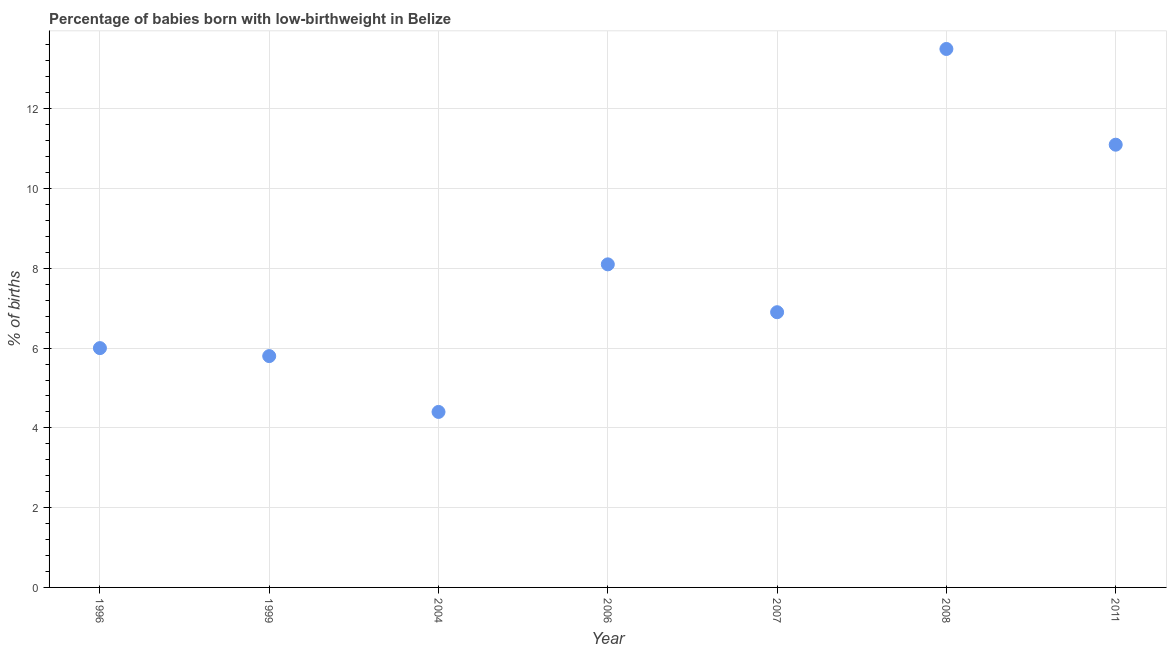Across all years, what is the maximum percentage of babies who were born with low-birthweight?
Provide a succinct answer. 13.5. Across all years, what is the minimum percentage of babies who were born with low-birthweight?
Your answer should be compact. 4.4. What is the sum of the percentage of babies who were born with low-birthweight?
Ensure brevity in your answer.  55.8. What is the average percentage of babies who were born with low-birthweight per year?
Provide a succinct answer. 7.97. In how many years, is the percentage of babies who were born with low-birthweight greater than 2.8 %?
Give a very brief answer. 7. What is the ratio of the percentage of babies who were born with low-birthweight in 2007 to that in 2011?
Your answer should be compact. 0.62. Is the percentage of babies who were born with low-birthweight in 2008 less than that in 2011?
Offer a very short reply. No. Is the difference between the percentage of babies who were born with low-birthweight in 1996 and 2004 greater than the difference between any two years?
Offer a very short reply. No. What is the difference between the highest and the second highest percentage of babies who were born with low-birthweight?
Your answer should be compact. 2.4. Is the sum of the percentage of babies who were born with low-birthweight in 2006 and 2007 greater than the maximum percentage of babies who were born with low-birthweight across all years?
Your response must be concise. Yes. What is the difference between the highest and the lowest percentage of babies who were born with low-birthweight?
Offer a terse response. 9.1. In how many years, is the percentage of babies who were born with low-birthweight greater than the average percentage of babies who were born with low-birthweight taken over all years?
Give a very brief answer. 3. Does the percentage of babies who were born with low-birthweight monotonically increase over the years?
Ensure brevity in your answer.  No. What is the difference between two consecutive major ticks on the Y-axis?
Offer a terse response. 2. Are the values on the major ticks of Y-axis written in scientific E-notation?
Make the answer very short. No. Does the graph contain any zero values?
Your answer should be very brief. No. Does the graph contain grids?
Make the answer very short. Yes. What is the title of the graph?
Keep it short and to the point. Percentage of babies born with low-birthweight in Belize. What is the label or title of the Y-axis?
Your answer should be compact. % of births. What is the % of births in 1996?
Provide a succinct answer. 6. What is the % of births in 2006?
Your response must be concise. 8.1. What is the % of births in 2007?
Your answer should be compact. 6.9. What is the difference between the % of births in 1996 and 1999?
Provide a succinct answer. 0.2. What is the difference between the % of births in 1996 and 2006?
Your answer should be compact. -2.1. What is the difference between the % of births in 1996 and 2008?
Keep it short and to the point. -7.5. What is the difference between the % of births in 1999 and 2008?
Offer a terse response. -7.7. What is the difference between the % of births in 2004 and 2007?
Your answer should be compact. -2.5. What is the difference between the % of births in 2004 and 2008?
Your answer should be compact. -9.1. What is the difference between the % of births in 2004 and 2011?
Ensure brevity in your answer.  -6.7. What is the difference between the % of births in 2006 and 2008?
Provide a succinct answer. -5.4. What is the difference between the % of births in 2006 and 2011?
Offer a very short reply. -3. What is the difference between the % of births in 2008 and 2011?
Ensure brevity in your answer.  2.4. What is the ratio of the % of births in 1996 to that in 1999?
Your response must be concise. 1.03. What is the ratio of the % of births in 1996 to that in 2004?
Offer a very short reply. 1.36. What is the ratio of the % of births in 1996 to that in 2006?
Your answer should be compact. 0.74. What is the ratio of the % of births in 1996 to that in 2007?
Provide a short and direct response. 0.87. What is the ratio of the % of births in 1996 to that in 2008?
Provide a short and direct response. 0.44. What is the ratio of the % of births in 1996 to that in 2011?
Offer a very short reply. 0.54. What is the ratio of the % of births in 1999 to that in 2004?
Ensure brevity in your answer.  1.32. What is the ratio of the % of births in 1999 to that in 2006?
Offer a terse response. 0.72. What is the ratio of the % of births in 1999 to that in 2007?
Your answer should be compact. 0.84. What is the ratio of the % of births in 1999 to that in 2008?
Your answer should be compact. 0.43. What is the ratio of the % of births in 1999 to that in 2011?
Give a very brief answer. 0.52. What is the ratio of the % of births in 2004 to that in 2006?
Your answer should be very brief. 0.54. What is the ratio of the % of births in 2004 to that in 2007?
Your answer should be very brief. 0.64. What is the ratio of the % of births in 2004 to that in 2008?
Your answer should be compact. 0.33. What is the ratio of the % of births in 2004 to that in 2011?
Provide a succinct answer. 0.4. What is the ratio of the % of births in 2006 to that in 2007?
Your answer should be very brief. 1.17. What is the ratio of the % of births in 2006 to that in 2011?
Ensure brevity in your answer.  0.73. What is the ratio of the % of births in 2007 to that in 2008?
Give a very brief answer. 0.51. What is the ratio of the % of births in 2007 to that in 2011?
Keep it short and to the point. 0.62. What is the ratio of the % of births in 2008 to that in 2011?
Keep it short and to the point. 1.22. 